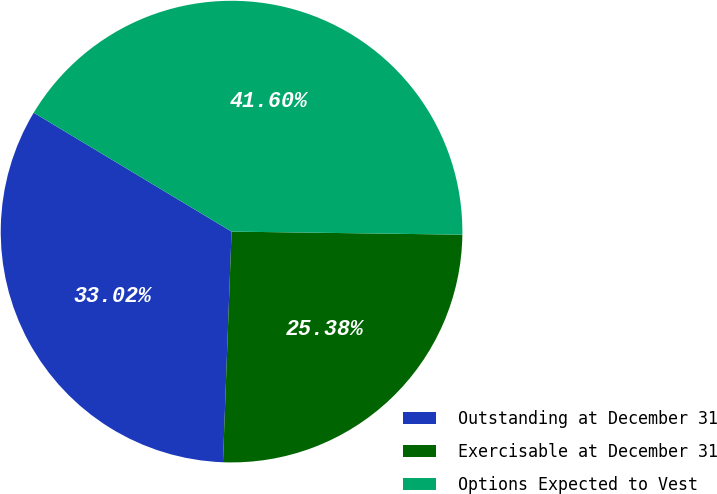Convert chart to OTSL. <chart><loc_0><loc_0><loc_500><loc_500><pie_chart><fcel>Outstanding at December 31<fcel>Exercisable at December 31<fcel>Options Expected to Vest<nl><fcel>33.02%<fcel>25.38%<fcel>41.6%<nl></chart> 